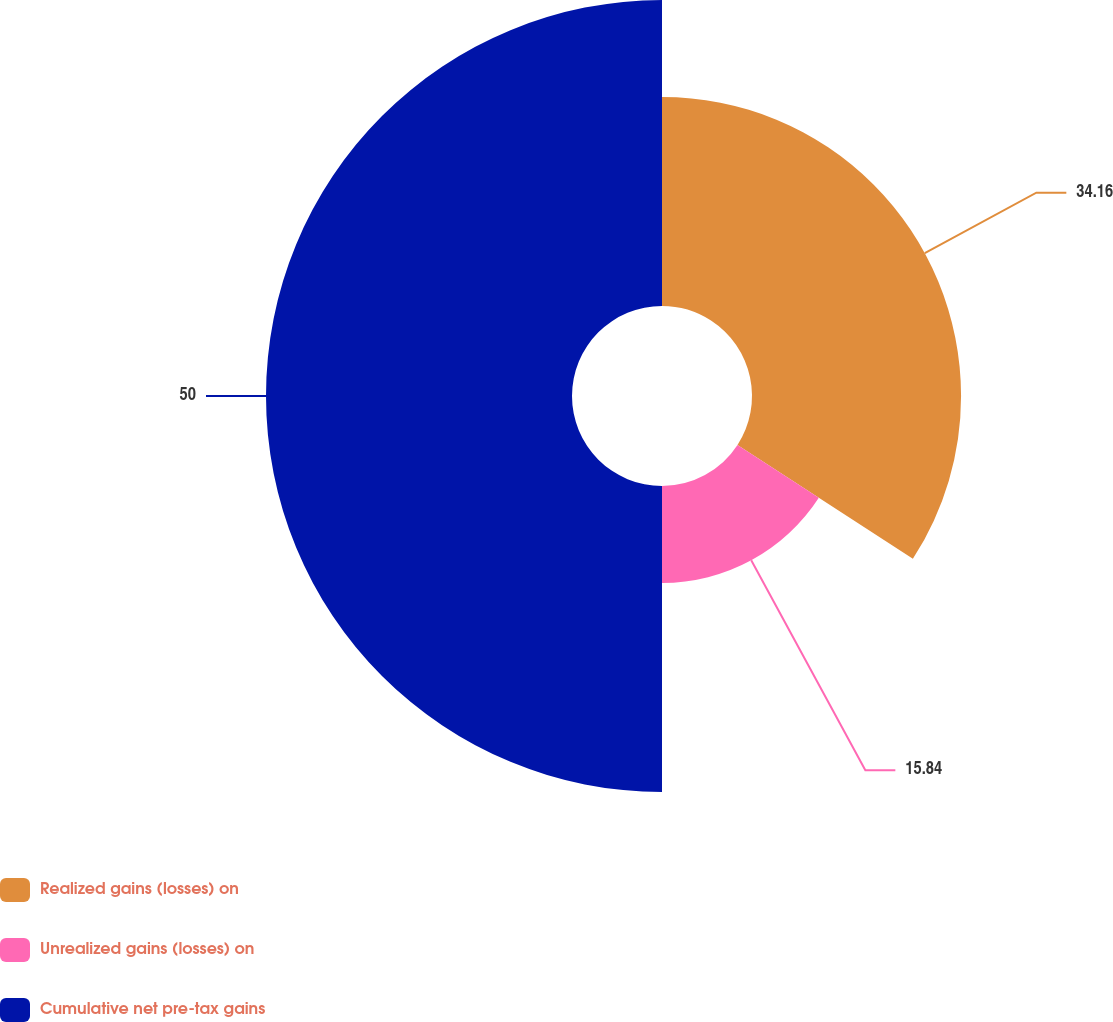Convert chart to OTSL. <chart><loc_0><loc_0><loc_500><loc_500><pie_chart><fcel>Realized gains (losses) on<fcel>Unrealized gains (losses) on<fcel>Cumulative net pre-tax gains<nl><fcel>34.16%<fcel>15.84%<fcel>50.0%<nl></chart> 